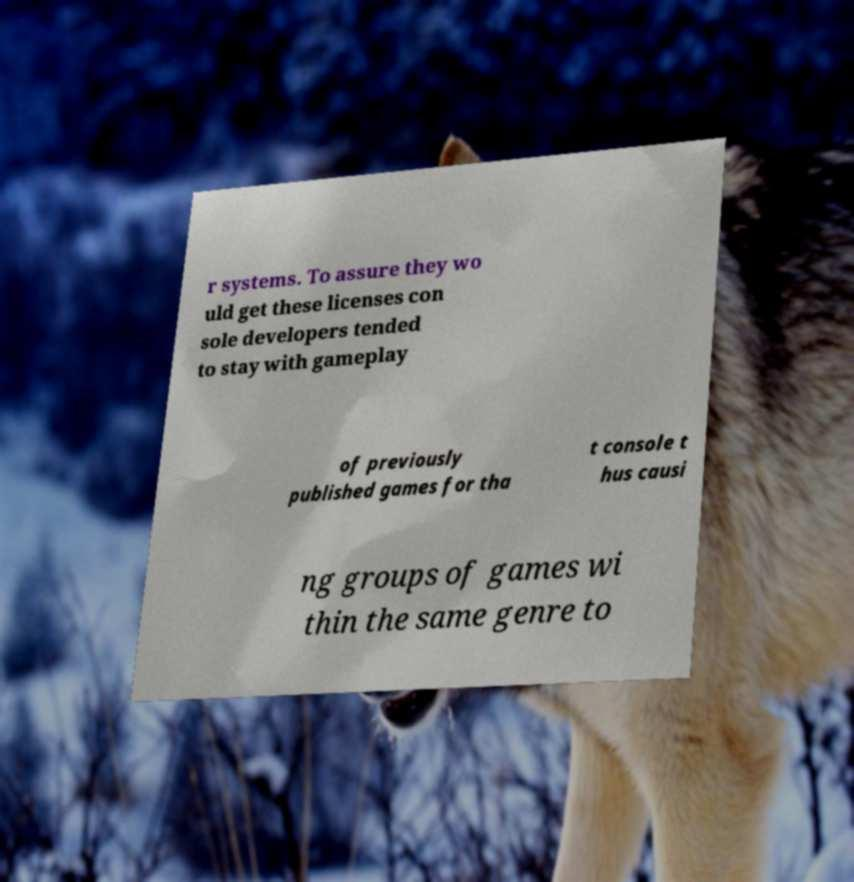Can you accurately transcribe the text from the provided image for me? r systems. To assure they wo uld get these licenses con sole developers tended to stay with gameplay of previously published games for tha t console t hus causi ng groups of games wi thin the same genre to 